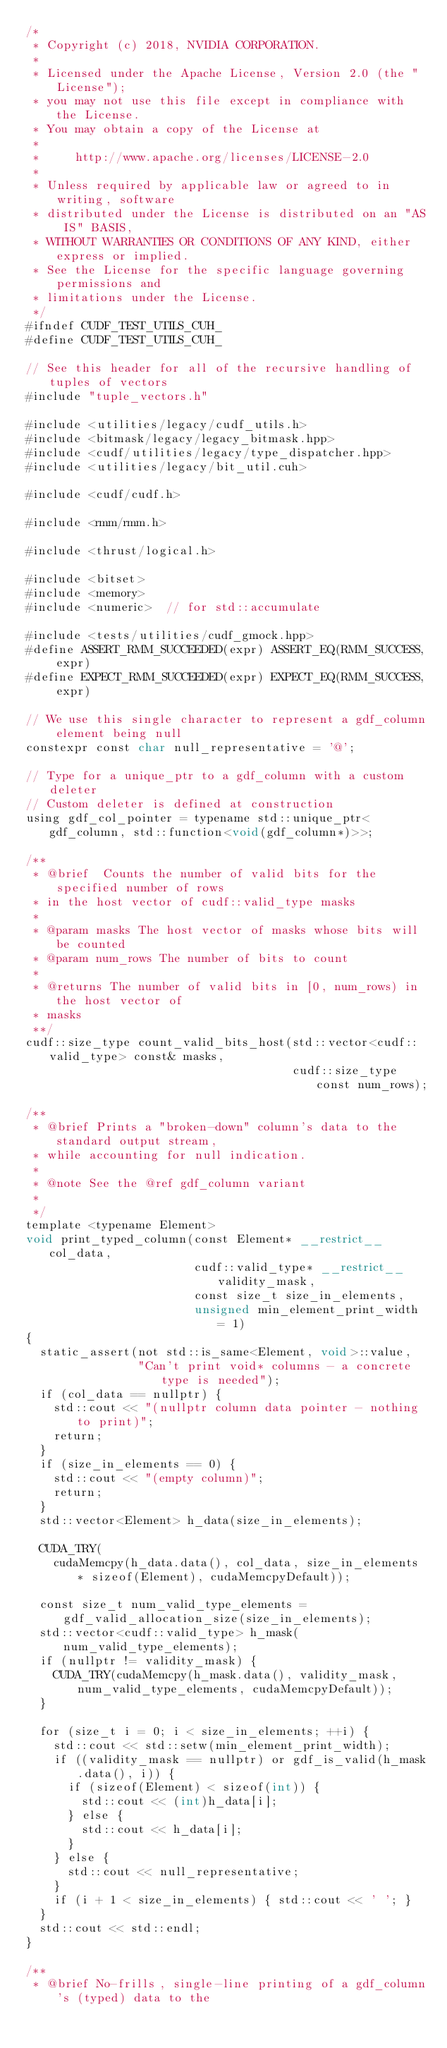<code> <loc_0><loc_0><loc_500><loc_500><_Cuda_>/*
 * Copyright (c) 2018, NVIDIA CORPORATION.
 *
 * Licensed under the Apache License, Version 2.0 (the "License");
 * you may not use this file except in compliance with the License.
 * You may obtain a copy of the License at
 *
 *     http://www.apache.org/licenses/LICENSE-2.0
 *
 * Unless required by applicable law or agreed to in writing, software
 * distributed under the License is distributed on an "AS IS" BASIS,
 * WITHOUT WARRANTIES OR CONDITIONS OF ANY KIND, either express or implied.
 * See the License for the specific language governing permissions and
 * limitations under the License.
 */
#ifndef CUDF_TEST_UTILS_CUH_
#define CUDF_TEST_UTILS_CUH_

// See this header for all of the recursive handling of tuples of vectors
#include "tuple_vectors.h"

#include <utilities/legacy/cudf_utils.h>
#include <bitmask/legacy/legacy_bitmask.hpp>
#include <cudf/utilities/legacy/type_dispatcher.hpp>
#include <utilities/legacy/bit_util.cuh>

#include <cudf/cudf.h>

#include <rmm/rmm.h>

#include <thrust/logical.h>

#include <bitset>
#include <memory>
#include <numeric>  // for std::accumulate

#include <tests/utilities/cudf_gmock.hpp>
#define ASSERT_RMM_SUCCEEDED(expr) ASSERT_EQ(RMM_SUCCESS, expr)
#define EXPECT_RMM_SUCCEEDED(expr) EXPECT_EQ(RMM_SUCCESS, expr)

// We use this single character to represent a gdf_column element being null
constexpr const char null_representative = '@';

// Type for a unique_ptr to a gdf_column with a custom deleter
// Custom deleter is defined at construction
using gdf_col_pointer = typename std::unique_ptr<gdf_column, std::function<void(gdf_column*)>>;

/**
 * @brief  Counts the number of valid bits for the specified number of rows
 * in the host vector of cudf::valid_type masks
 *
 * @param masks The host vector of masks whose bits will be counted
 * @param num_rows The number of bits to count
 *
 * @returns The number of valid bits in [0, num_rows) in the host vector of
 * masks
 **/
cudf::size_type count_valid_bits_host(std::vector<cudf::valid_type> const& masks,
                                      cudf::size_type const num_rows);

/**
 * @brief Prints a "broken-down" column's data to the standard output stream,
 * while accounting for null indication.
 *
 * @note See the @ref gdf_column variant
 *
 */
template <typename Element>
void print_typed_column(const Element* __restrict__ col_data,
                        cudf::valid_type* __restrict__ validity_mask,
                        const size_t size_in_elements,
                        unsigned min_element_print_width = 1)
{
  static_assert(not std::is_same<Element, void>::value,
                "Can't print void* columns - a concrete type is needed");
  if (col_data == nullptr) {
    std::cout << "(nullptr column data pointer - nothing to print)";
    return;
  }
  if (size_in_elements == 0) {
    std::cout << "(empty column)";
    return;
  }
  std::vector<Element> h_data(size_in_elements);

  CUDA_TRY(
    cudaMemcpy(h_data.data(), col_data, size_in_elements * sizeof(Element), cudaMemcpyDefault));

  const size_t num_valid_type_elements = gdf_valid_allocation_size(size_in_elements);
  std::vector<cudf::valid_type> h_mask(num_valid_type_elements);
  if (nullptr != validity_mask) {
    CUDA_TRY(cudaMemcpy(h_mask.data(), validity_mask, num_valid_type_elements, cudaMemcpyDefault));
  }

  for (size_t i = 0; i < size_in_elements; ++i) {
    std::cout << std::setw(min_element_print_width);
    if ((validity_mask == nullptr) or gdf_is_valid(h_mask.data(), i)) {
      if (sizeof(Element) < sizeof(int)) {
        std::cout << (int)h_data[i];
      } else {
        std::cout << h_data[i];
      }
    } else {
      std::cout << null_representative;
    }
    if (i + 1 < size_in_elements) { std::cout << ' '; }
  }
  std::cout << std::endl;
}

/**
 * @brief No-frills, single-line printing of a gdf_column's (typed) data to the</code> 